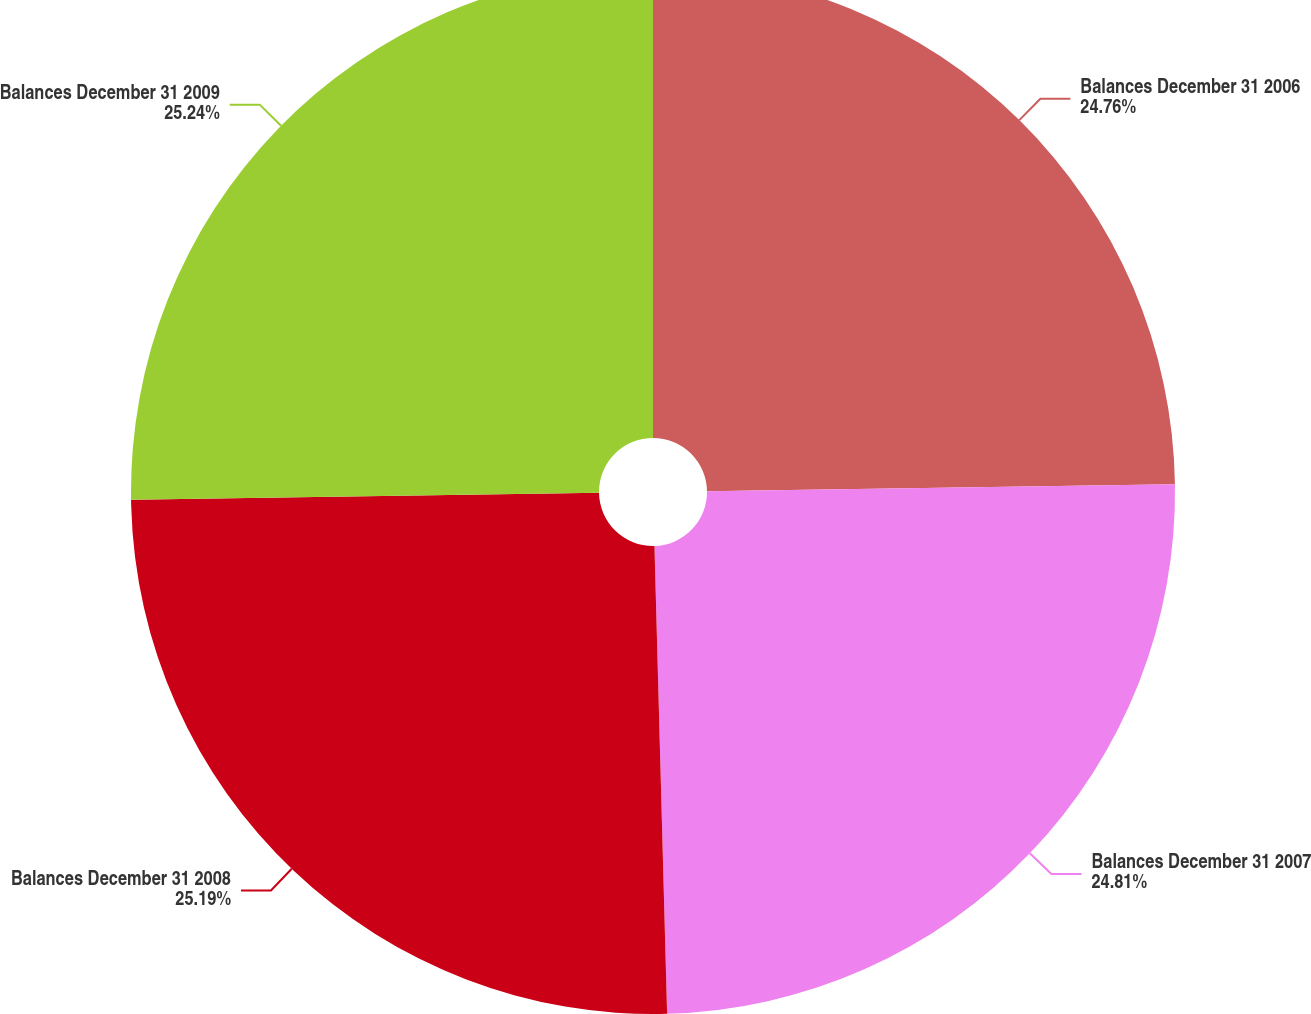<chart> <loc_0><loc_0><loc_500><loc_500><pie_chart><fcel>Balances December 31 2006<fcel>Balances December 31 2007<fcel>Balances December 31 2008<fcel>Balances December 31 2009<nl><fcel>24.76%<fcel>24.81%<fcel>25.19%<fcel>25.24%<nl></chart> 